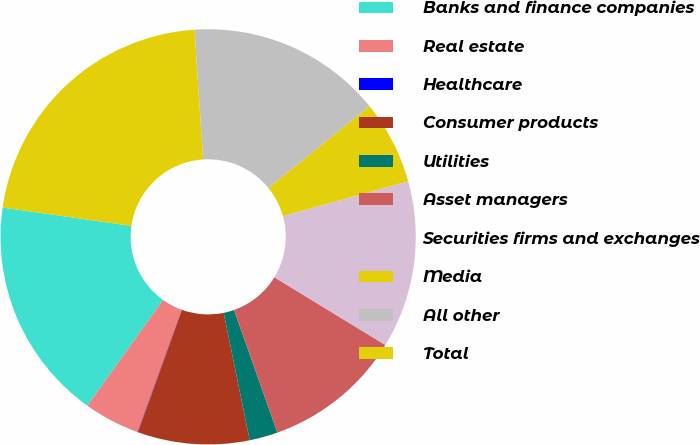Convert chart. <chart><loc_0><loc_0><loc_500><loc_500><pie_chart><fcel>Banks and finance companies<fcel>Real estate<fcel>Healthcare<fcel>Consumer products<fcel>Utilities<fcel>Asset managers<fcel>Securities firms and exchanges<fcel>Media<fcel>All other<fcel>Total<nl><fcel>17.37%<fcel>4.36%<fcel>0.03%<fcel>8.7%<fcel>2.2%<fcel>10.87%<fcel>13.03%<fcel>6.53%<fcel>15.2%<fcel>21.7%<nl></chart> 